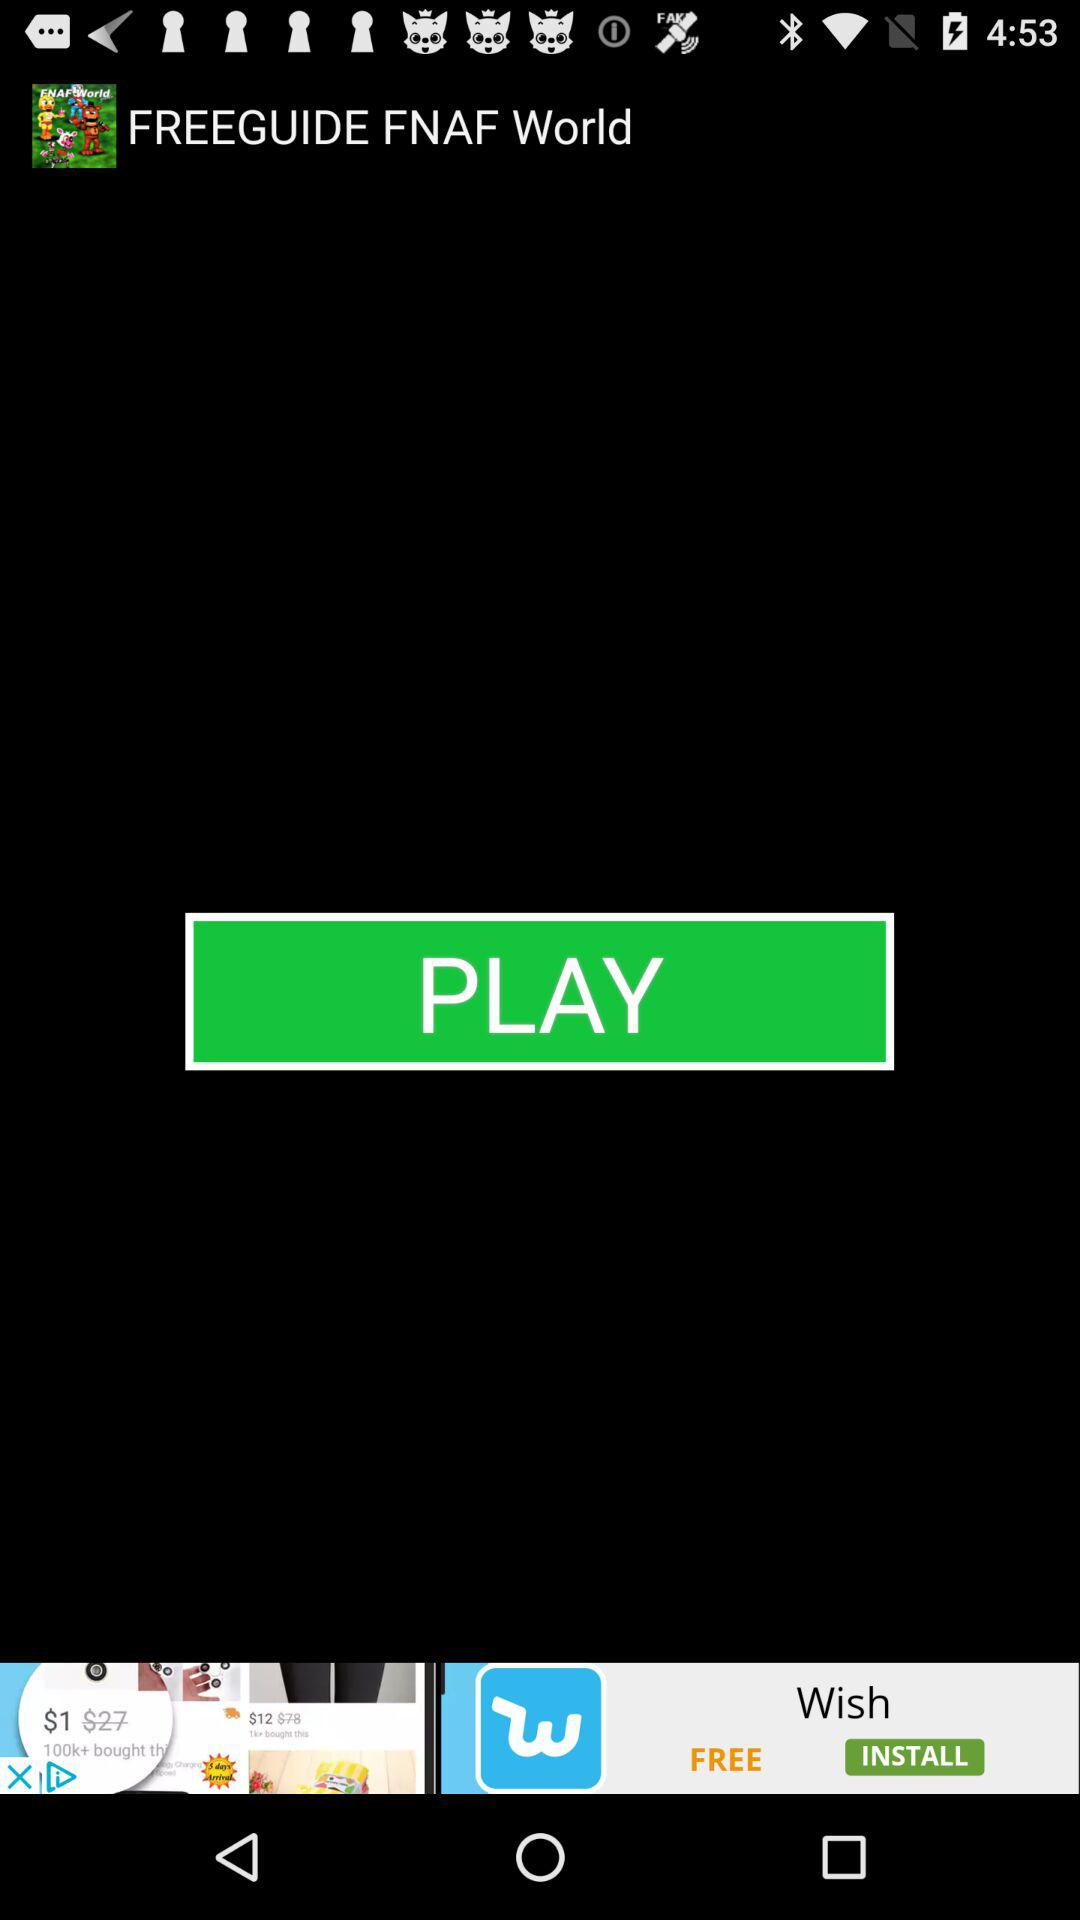What is the app name? The app name is "FREEGUIDE FNAF World". 